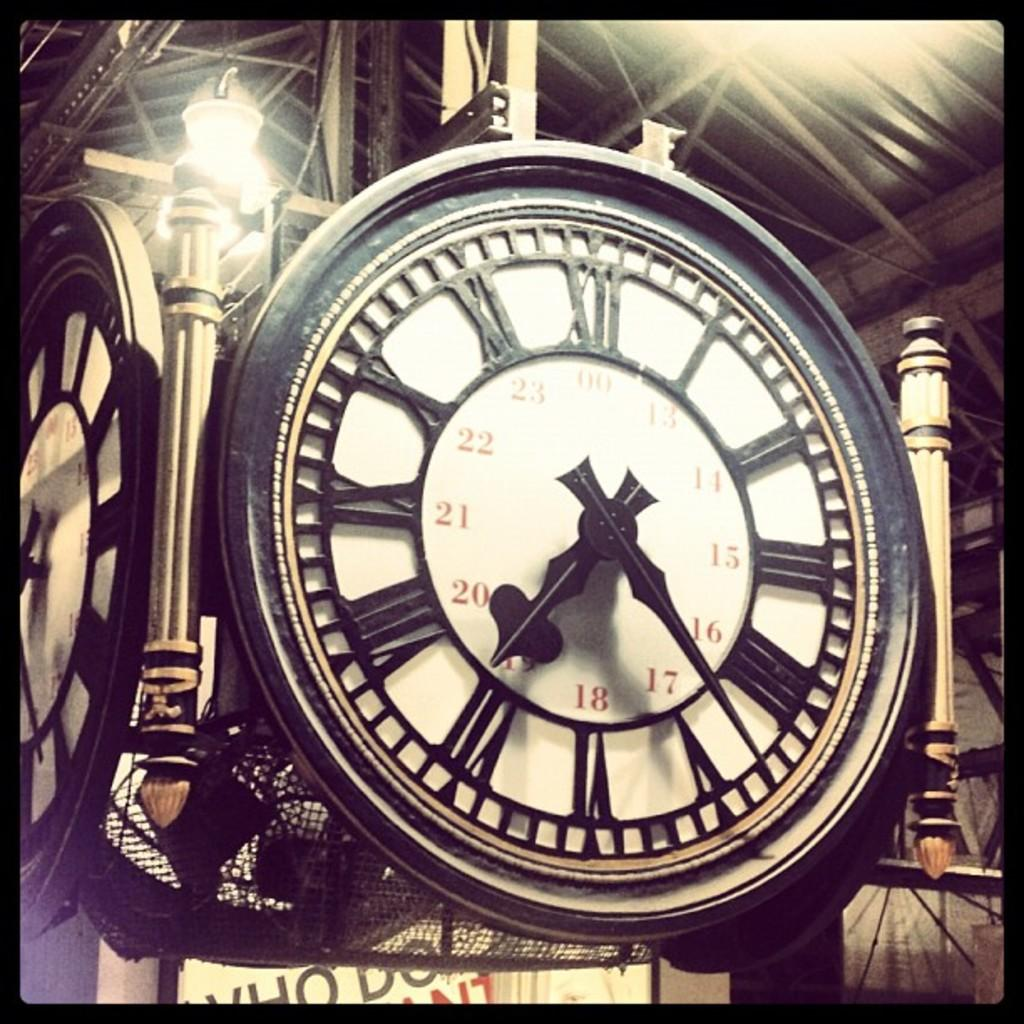<image>
Create a compact narrative representing the image presented. A clock has the number 18 at the bottom and the number 00 at the top. 